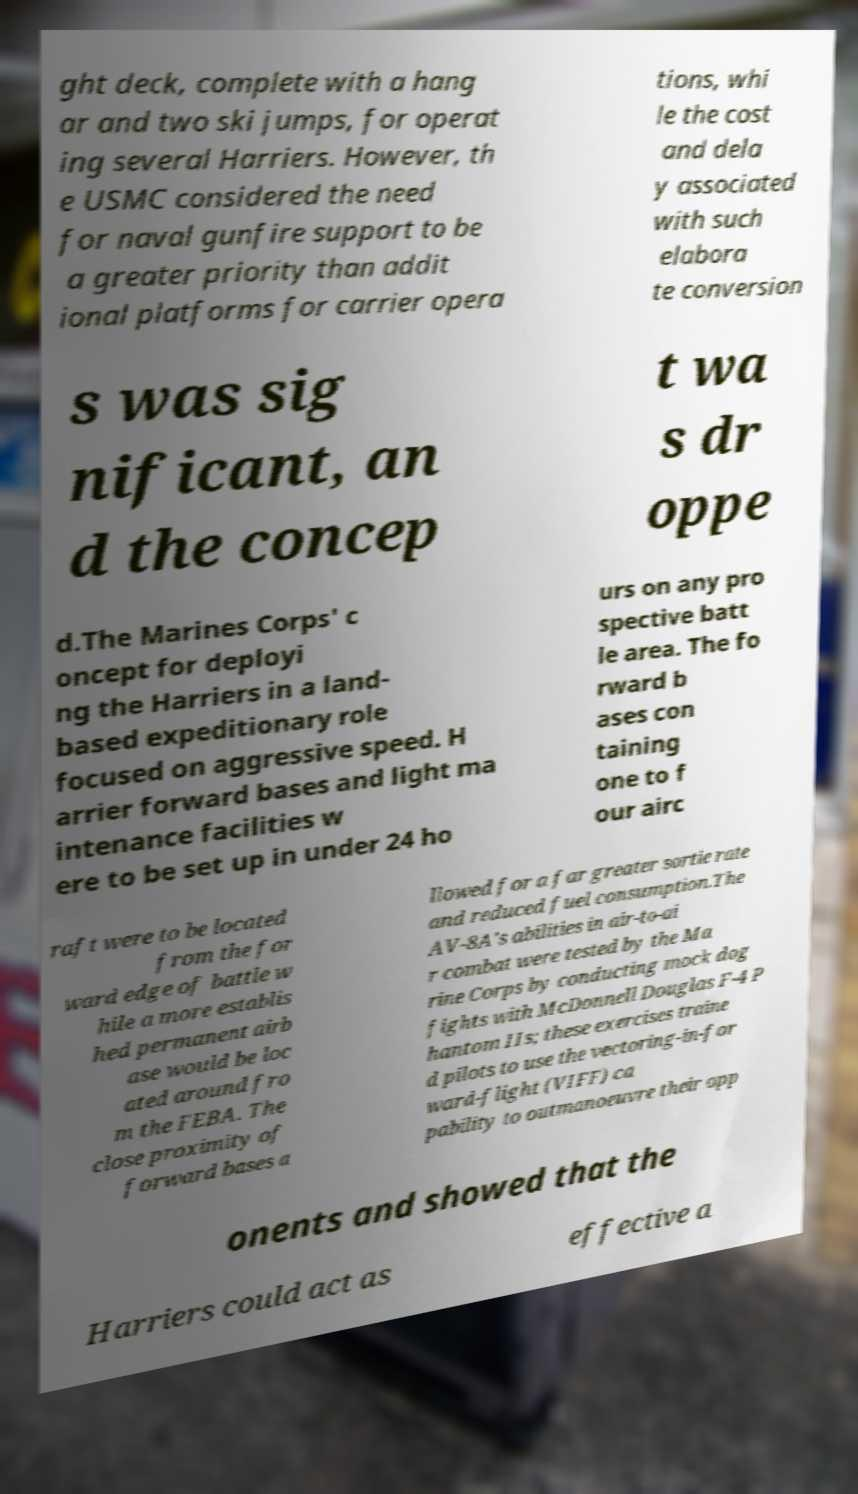For documentation purposes, I need the text within this image transcribed. Could you provide that? ght deck, complete with a hang ar and two ski jumps, for operat ing several Harriers. However, th e USMC considered the need for naval gunfire support to be a greater priority than addit ional platforms for carrier opera tions, whi le the cost and dela y associated with such elabora te conversion s was sig nificant, an d the concep t wa s dr oppe d.The Marines Corps' c oncept for deployi ng the Harriers in a land- based expeditionary role focused on aggressive speed. H arrier forward bases and light ma intenance facilities w ere to be set up in under 24 ho urs on any pro spective batt le area. The fo rward b ases con taining one to f our airc raft were to be located from the for ward edge of battle w hile a more establis hed permanent airb ase would be loc ated around fro m the FEBA. The close proximity of forward bases a llowed for a far greater sortie rate and reduced fuel consumption.The AV-8A's abilities in air-to-ai r combat were tested by the Ma rine Corps by conducting mock dog fights with McDonnell Douglas F-4 P hantom IIs; these exercises traine d pilots to use the vectoring-in-for ward-flight (VIFF) ca pability to outmanoeuvre their opp onents and showed that the Harriers could act as effective a 